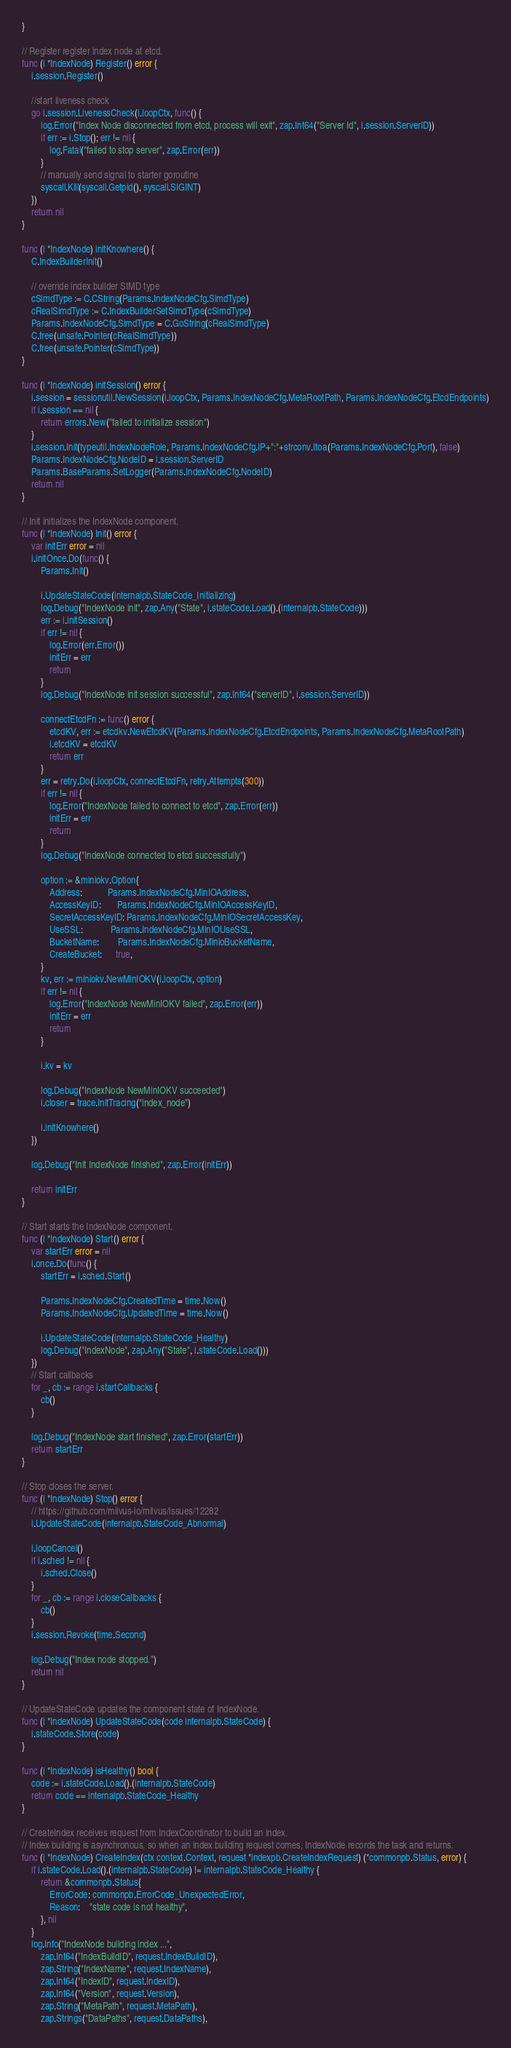Convert code to text. <code><loc_0><loc_0><loc_500><loc_500><_Go_>}

// Register register index node at etcd.
func (i *IndexNode) Register() error {
	i.session.Register()

	//start liveness check
	go i.session.LivenessCheck(i.loopCtx, func() {
		log.Error("Index Node disconnected from etcd, process will exit", zap.Int64("Server Id", i.session.ServerID))
		if err := i.Stop(); err != nil {
			log.Fatal("failed to stop server", zap.Error(err))
		}
		// manually send signal to starter goroutine
		syscall.Kill(syscall.Getpid(), syscall.SIGINT)
	})
	return nil
}

func (i *IndexNode) initKnowhere() {
	C.IndexBuilderInit()

	// override index builder SIMD type
	cSimdType := C.CString(Params.IndexNodeCfg.SimdType)
	cRealSimdType := C.IndexBuilderSetSimdType(cSimdType)
	Params.IndexNodeCfg.SimdType = C.GoString(cRealSimdType)
	C.free(unsafe.Pointer(cRealSimdType))
	C.free(unsafe.Pointer(cSimdType))
}

func (i *IndexNode) initSession() error {
	i.session = sessionutil.NewSession(i.loopCtx, Params.IndexNodeCfg.MetaRootPath, Params.IndexNodeCfg.EtcdEndpoints)
	if i.session == nil {
		return errors.New("failed to initialize session")
	}
	i.session.Init(typeutil.IndexNodeRole, Params.IndexNodeCfg.IP+":"+strconv.Itoa(Params.IndexNodeCfg.Port), false)
	Params.IndexNodeCfg.NodeID = i.session.ServerID
	Params.BaseParams.SetLogger(Params.IndexNodeCfg.NodeID)
	return nil
}

// Init initializes the IndexNode component.
func (i *IndexNode) Init() error {
	var initErr error = nil
	i.initOnce.Do(func() {
		Params.Init()

		i.UpdateStateCode(internalpb.StateCode_Initializing)
		log.Debug("IndexNode init", zap.Any("State", i.stateCode.Load().(internalpb.StateCode)))
		err := i.initSession()
		if err != nil {
			log.Error(err.Error())
			initErr = err
			return
		}
		log.Debug("IndexNode init session successful", zap.Int64("serverID", i.session.ServerID))

		connectEtcdFn := func() error {
			etcdKV, err := etcdkv.NewEtcdKV(Params.IndexNodeCfg.EtcdEndpoints, Params.IndexNodeCfg.MetaRootPath)
			i.etcdKV = etcdKV
			return err
		}
		err = retry.Do(i.loopCtx, connectEtcdFn, retry.Attempts(300))
		if err != nil {
			log.Error("IndexNode failed to connect to etcd", zap.Error(err))
			initErr = err
			return
		}
		log.Debug("IndexNode connected to etcd successfully")

		option := &miniokv.Option{
			Address:           Params.IndexNodeCfg.MinIOAddress,
			AccessKeyID:       Params.IndexNodeCfg.MinIOAccessKeyID,
			SecretAccessKeyID: Params.IndexNodeCfg.MinIOSecretAccessKey,
			UseSSL:            Params.IndexNodeCfg.MinIOUseSSL,
			BucketName:        Params.IndexNodeCfg.MinioBucketName,
			CreateBucket:      true,
		}
		kv, err := miniokv.NewMinIOKV(i.loopCtx, option)
		if err != nil {
			log.Error("IndexNode NewMinIOKV failed", zap.Error(err))
			initErr = err
			return
		}

		i.kv = kv

		log.Debug("IndexNode NewMinIOKV succeeded")
		i.closer = trace.InitTracing("index_node")

		i.initKnowhere()
	})

	log.Debug("Init IndexNode finished", zap.Error(initErr))

	return initErr
}

// Start starts the IndexNode component.
func (i *IndexNode) Start() error {
	var startErr error = nil
	i.once.Do(func() {
		startErr = i.sched.Start()

		Params.IndexNodeCfg.CreatedTime = time.Now()
		Params.IndexNodeCfg.UpdatedTime = time.Now()

		i.UpdateStateCode(internalpb.StateCode_Healthy)
		log.Debug("IndexNode", zap.Any("State", i.stateCode.Load()))
	})
	// Start callbacks
	for _, cb := range i.startCallbacks {
		cb()
	}

	log.Debug("IndexNode start finished", zap.Error(startErr))
	return startErr
}

// Stop closes the server.
func (i *IndexNode) Stop() error {
	// https://github.com/milvus-io/milvus/issues/12282
	i.UpdateStateCode(internalpb.StateCode_Abnormal)

	i.loopCancel()
	if i.sched != nil {
		i.sched.Close()
	}
	for _, cb := range i.closeCallbacks {
		cb()
	}
	i.session.Revoke(time.Second)

	log.Debug("Index node stopped.")
	return nil
}

// UpdateStateCode updates the component state of IndexNode.
func (i *IndexNode) UpdateStateCode(code internalpb.StateCode) {
	i.stateCode.Store(code)
}

func (i *IndexNode) isHealthy() bool {
	code := i.stateCode.Load().(internalpb.StateCode)
	return code == internalpb.StateCode_Healthy
}

// CreateIndex receives request from IndexCoordinator to build an index.
// Index building is asynchronous, so when an index building request comes, IndexNode records the task and returns.
func (i *IndexNode) CreateIndex(ctx context.Context, request *indexpb.CreateIndexRequest) (*commonpb.Status, error) {
	if i.stateCode.Load().(internalpb.StateCode) != internalpb.StateCode_Healthy {
		return &commonpb.Status{
			ErrorCode: commonpb.ErrorCode_UnexpectedError,
			Reason:    "state code is not healthy",
		}, nil
	}
	log.Info("IndexNode building index ...",
		zap.Int64("IndexBuildID", request.IndexBuildID),
		zap.String("IndexName", request.IndexName),
		zap.Int64("IndexID", request.IndexID),
		zap.Int64("Version", request.Version),
		zap.String("MetaPath", request.MetaPath),
		zap.Strings("DataPaths", request.DataPaths),</code> 